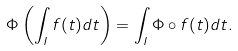Convert formula to latex. <formula><loc_0><loc_0><loc_500><loc_500>\Phi \left ( \int _ { I } f ( t ) d t \right ) = \int _ { I } \Phi \circ f ( t ) d t .</formula> 